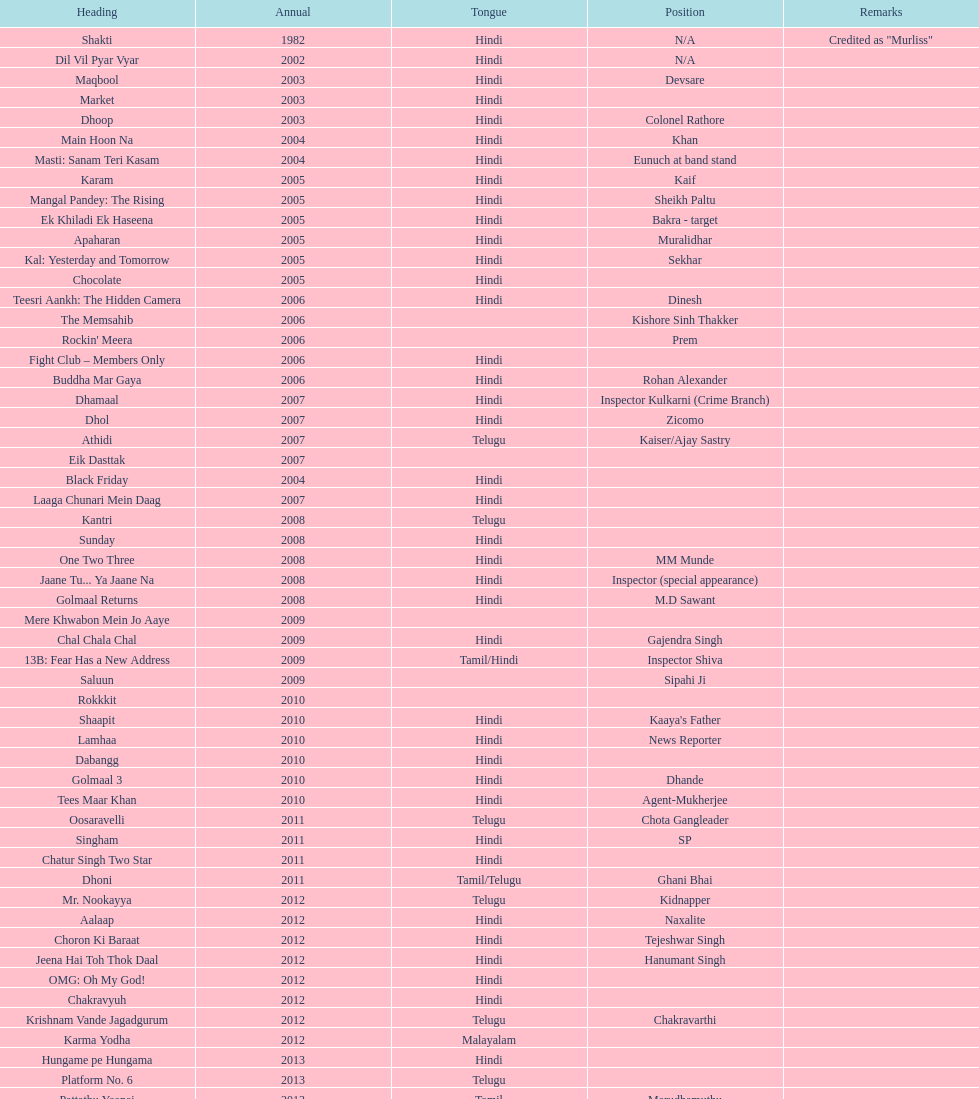Which motion picture featured this actor subsequent to starring in dil vil pyar vyar in 2002? Maqbool. 